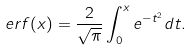<formula> <loc_0><loc_0><loc_500><loc_500>e r f ( x ) = \frac { 2 } { \sqrt { \pi } } \int _ { 0 } ^ { x } e ^ { - t ^ { 2 } } d t .</formula> 